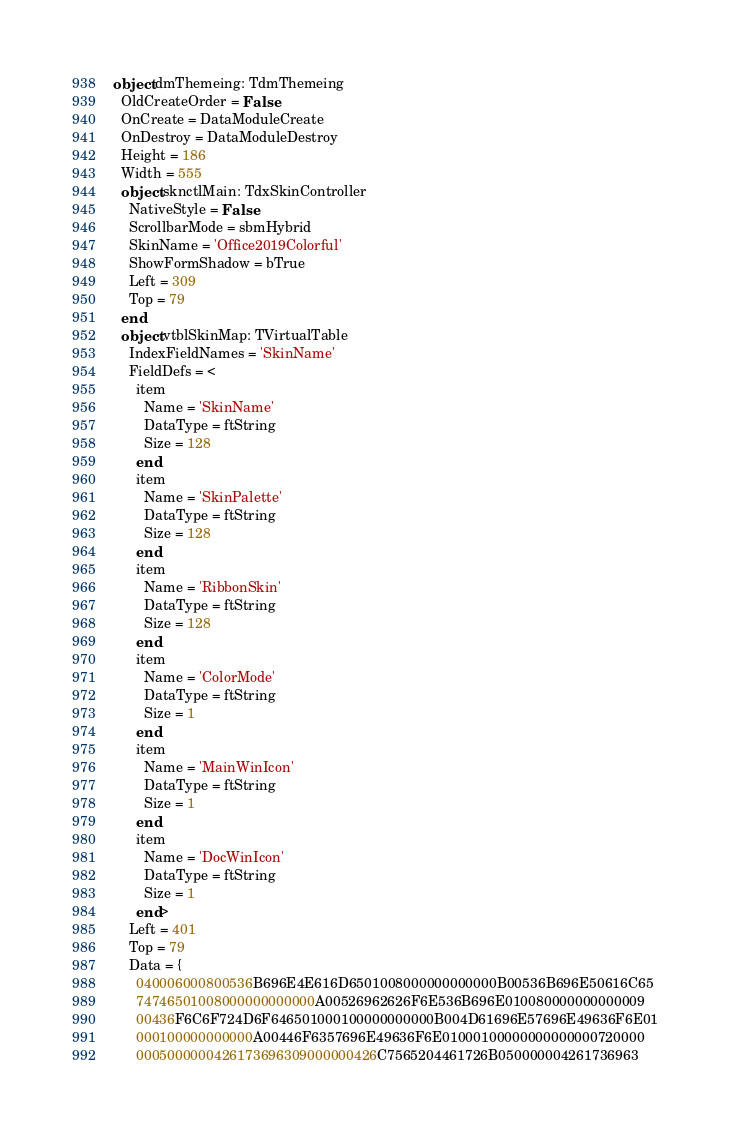Convert code to text. <code><loc_0><loc_0><loc_500><loc_500><_Pascal_>object dmThemeing: TdmThemeing
  OldCreateOrder = False
  OnCreate = DataModuleCreate
  OnDestroy = DataModuleDestroy
  Height = 186
  Width = 555
  object sknctlMain: TdxSkinController
    NativeStyle = False
    ScrollbarMode = sbmHybrid
    SkinName = 'Office2019Colorful'
    ShowFormShadow = bTrue
    Left = 309
    Top = 79
  end
  object vtblSkinMap: TVirtualTable
    IndexFieldNames = 'SkinName'
    FieldDefs = <
      item
        Name = 'SkinName'
        DataType = ftString
        Size = 128
      end
      item
        Name = 'SkinPalette'
        DataType = ftString
        Size = 128
      end
      item
        Name = 'RibbonSkin'
        DataType = ftString
        Size = 128
      end
      item
        Name = 'ColorMode'
        DataType = ftString
        Size = 1
      end
      item
        Name = 'MainWinIcon'
        DataType = ftString
        Size = 1
      end
      item
        Name = 'DocWinIcon'
        DataType = ftString
        Size = 1
      end>
    Left = 401
    Top = 79
    Data = {
      040006000800536B696E4E616D6501008000000000000B00536B696E50616C65
      74746501008000000000000A00526962626F6E536B696E010080000000000009
      00436F6C6F724D6F646501000100000000000B004D61696E57696E49636F6E01
      000100000000000A00446F6357696E49636F6E01000100000000000000720000
      0005000000426173696309000000426C7565204461726B050000004261736963</code> 